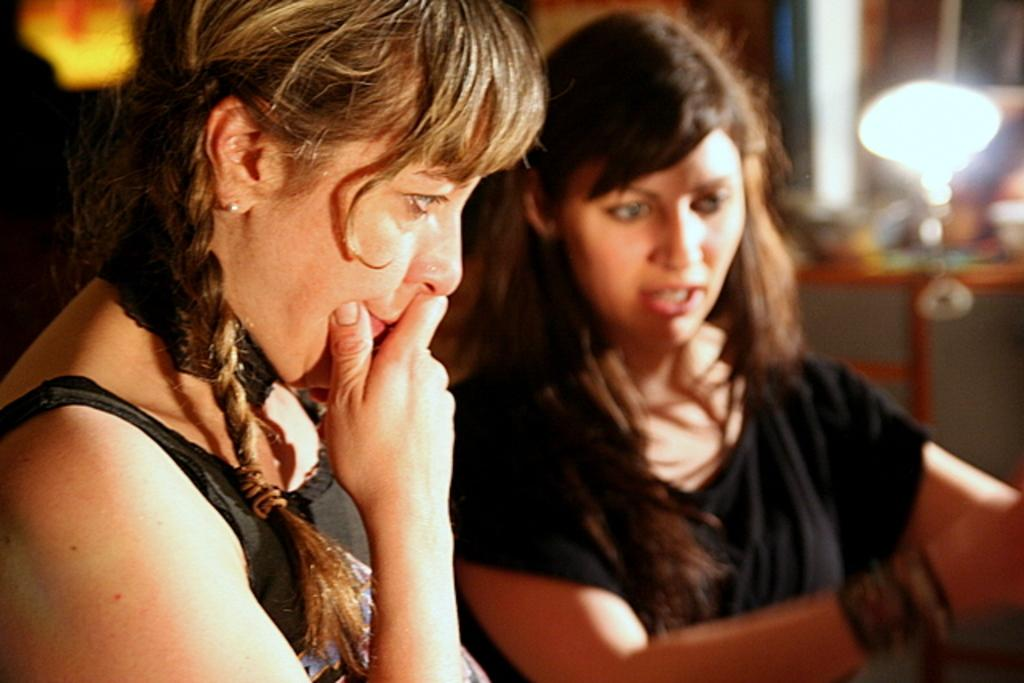Who is present in the image? There are women in the image. What can be seen in the image that provides illumination? There is a light in the image. What is visible in the background of the image? There are items on a table in the background of the image. Can you tell me how many rats are hiding under the table in the image? There are no rats present in the image; only the women, light, and items on the table are visible. 